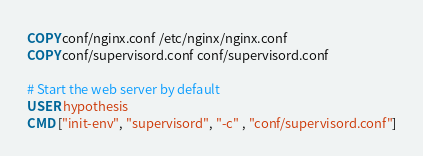<code> <loc_0><loc_0><loc_500><loc_500><_Dockerfile_>COPY conf/nginx.conf /etc/nginx/nginx.conf
COPY conf/supervisord.conf conf/supervisord.conf

# Start the web server by default
USER hypothesis
CMD ["init-env", "supervisord", "-c" , "conf/supervisord.conf"]
</code> 